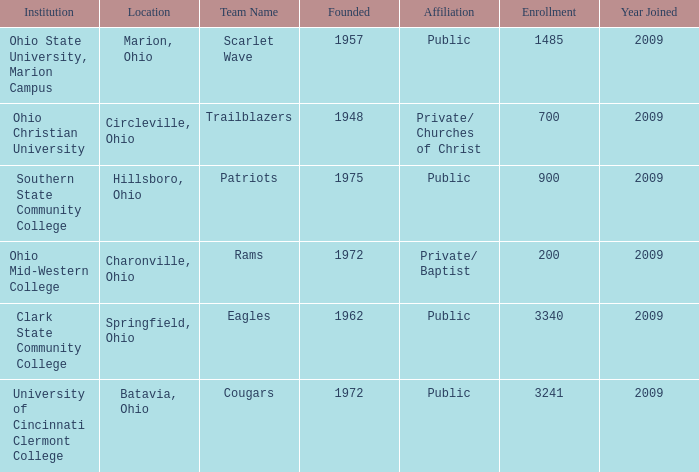What is the location when founded was 1957? Marion, Ohio. 